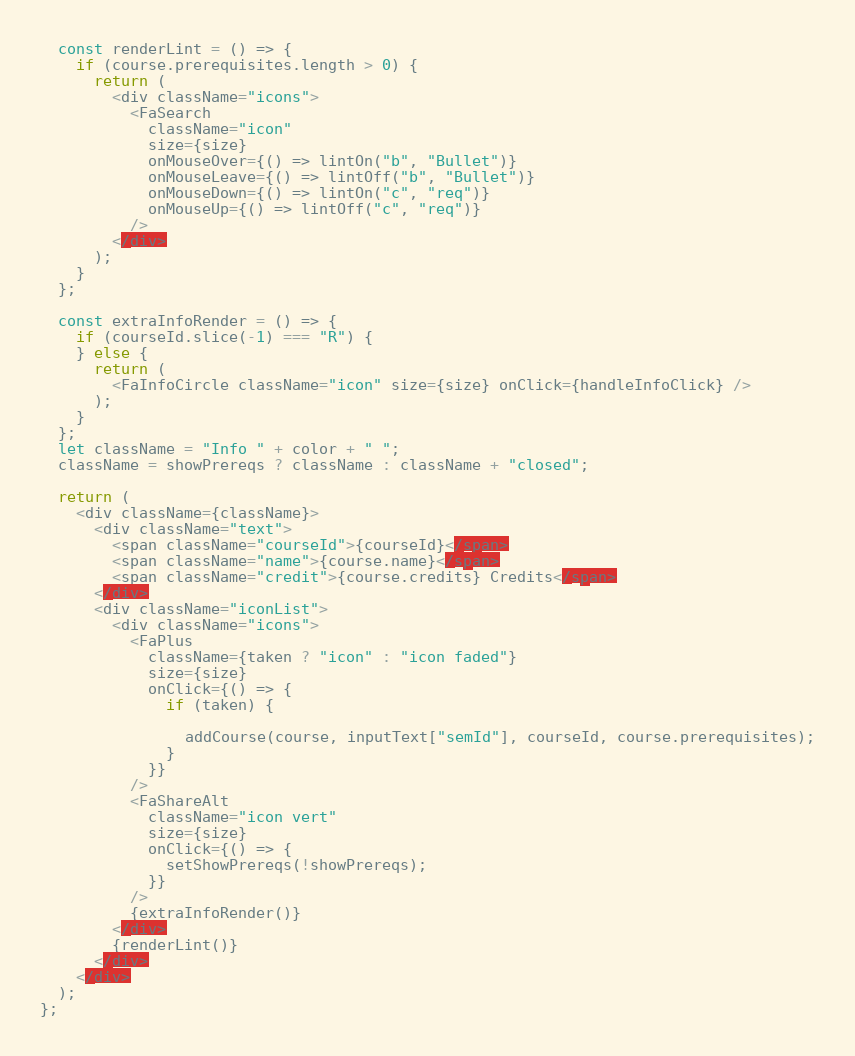<code> <loc_0><loc_0><loc_500><loc_500><_JavaScript_>
  const renderLint = () => {
    if (course.prerequisites.length > 0) {
      return (
        <div className="icons">
          <FaSearch
            className="icon"
            size={size}
            onMouseOver={() => lintOn("b", "Bullet")}
            onMouseLeave={() => lintOff("b", "Bullet")}
            onMouseDown={() => lintOn("c", "req")}
            onMouseUp={() => lintOff("c", "req")}
          />
        </div>
      );
    }
  };

  const extraInfoRender = () => {
    if (courseId.slice(-1) === "R") {
    } else {
      return (
        <FaInfoCircle className="icon" size={size} onClick={handleInfoClick} />
      );
    }
  };
  let className = "Info " + color + " ";
  className = showPrereqs ? className : className + "closed";

  return (
    <div className={className}>
      <div className="text">
        <span className="courseId">{courseId}</span>
        <span className="name">{course.name}</span>
        <span className="credit">{course.credits} Credits</span>
      </div>
      <div className="iconList">
        <div className="icons">
          <FaPlus
            className={taken ? "icon" : "icon faded"}
            size={size}
            onClick={() => {
              if (taken) {
              
                addCourse(course, inputText["semId"], courseId, course.prerequisites);
              }
            }}
          />
          <FaShareAlt
            className="icon vert"
            size={size}
            onClick={() => {
              setShowPrereqs(!showPrereqs);
            }}
          />
          {extraInfoRender()}
        </div>
        {renderLint()}
      </div>
    </div>
  );
};
</code> 